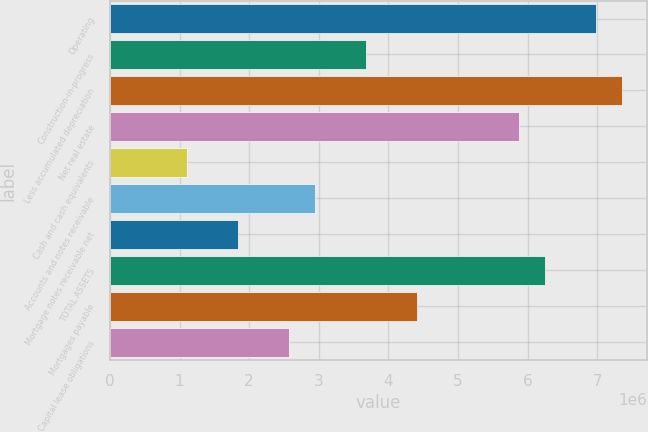Convert chart. <chart><loc_0><loc_0><loc_500><loc_500><bar_chart><fcel>Operating<fcel>Construction-in-progress<fcel>Less accumulated depreciation<fcel>Net real estate<fcel>Cash and cash equivalents<fcel>Accounts and notes receivable<fcel>Mortgage notes receivable net<fcel>TOTAL ASSETS<fcel>Mortgages payable<fcel>Capital lease obligations<nl><fcel>6.97947e+06<fcel>3.67368e+06<fcel>7.34678e+06<fcel>5.87754e+06<fcel>1.10252e+06<fcel>2.93907e+06<fcel>1.83714e+06<fcel>6.24485e+06<fcel>4.4083e+06<fcel>2.57176e+06<nl></chart> 